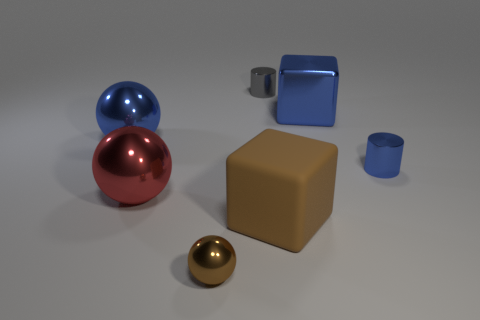Can you guess the size of these objects relative to each other? The gold sphere is the smallest, followed by the blue cup. The red sphere and blue sphere are larger, with the blue sphere being slightly larger than the red one. The brown cube and blue hollow cube appear to be the largest objects in the scene. Could you put them in a specific order based on their size? From smallest to largest: gold sphere, blue cup, red sphere, blue sphere, brown cube, and blue hollow cube. 